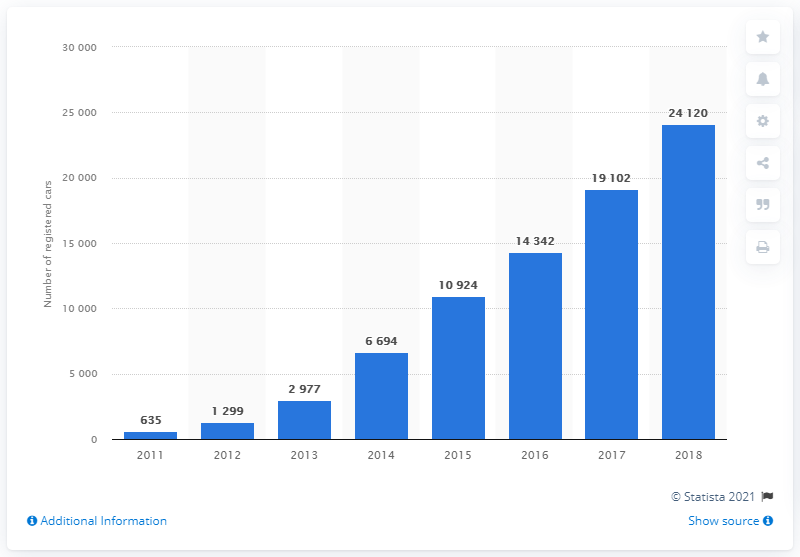Specify some key components in this picture. The difference between the second highest and second least cars is 17,803. In 2017, the number of cars was 19,102. 